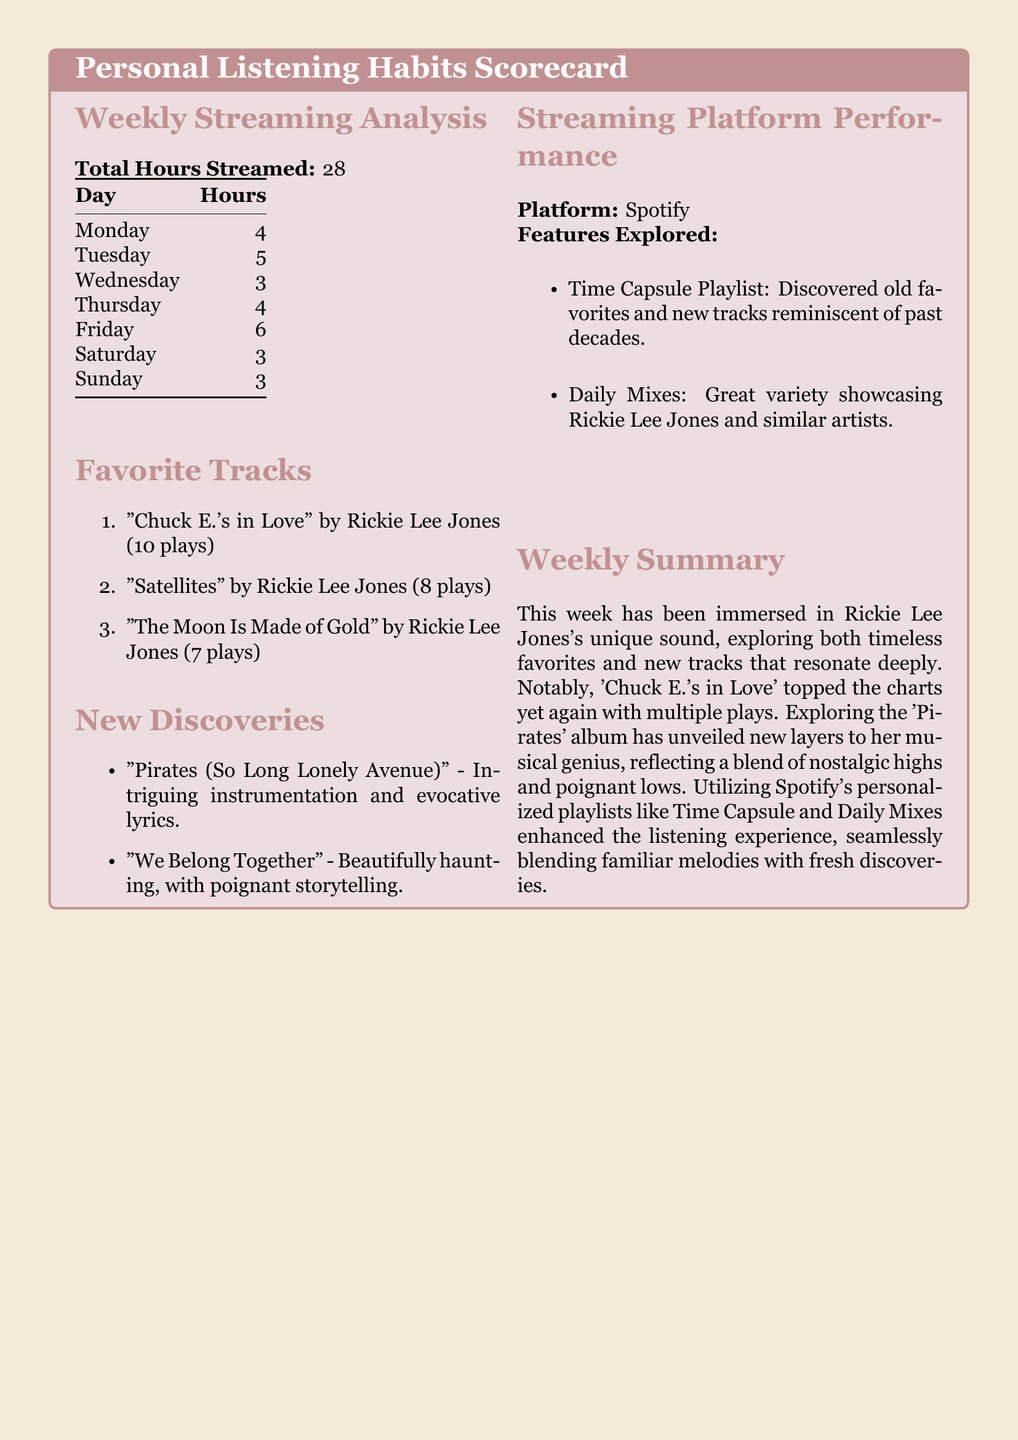What is the total hours streamed? The total hours streamed is indicated at the top of the Weekly Streaming Analysis section.
Answer: 28 Which track has the most plays? The track with the most plays is listed first in the Favorite Tracks section.
Answer: "Chuck E.'s in Love" How many times was "Satellites" played? The number of plays for "Satellites" is detailed in the Favorite Tracks section.
Answer: 8 What is the primary streaming platform used? The primary streaming platform is stated in the Streaming Platform Performance section.
Answer: Spotify How many hours were streamed on Friday? The hours streamed on Friday can be found in the Weekly Streaming Analysis table.
Answer: 6 What new track features evocative lyrics? The new tracks are noted in the New Discoveries section, mentioning intriguing elements.
Answer: "Pirates (So Long Lonely Avenue)" What playlists did the user explore? The explored playlists are listed in the Streaming Platform Performance section.
Answer: Time Capsule Playlist and Daily Mixes What is emphasized in the weekly summary? The weekly summary focuses on the unique sound and new layers explored.
Answer: Rickie Lee Jones's unique sound How many plays does "The Moon Is Made of Gold" have? The number of plays for "The Moon Is Made of Gold" is indicated in the Favorite Tracks section.
Answer: 7 